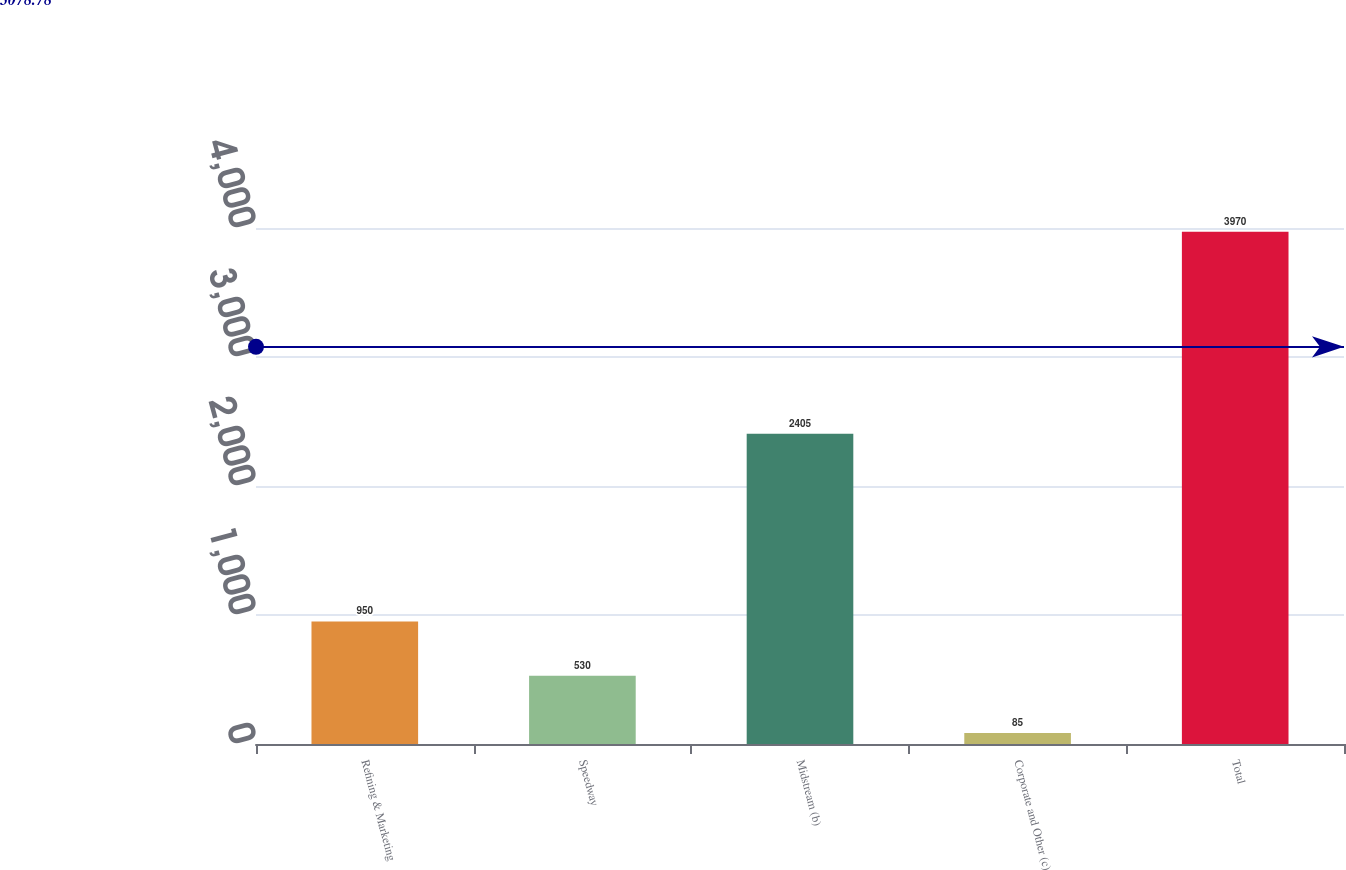Convert chart to OTSL. <chart><loc_0><loc_0><loc_500><loc_500><bar_chart><fcel>Refining & Marketing<fcel>Speedway<fcel>Midstream (b)<fcel>Corporate and Other (c)<fcel>Total<nl><fcel>950<fcel>530<fcel>2405<fcel>85<fcel>3970<nl></chart> 